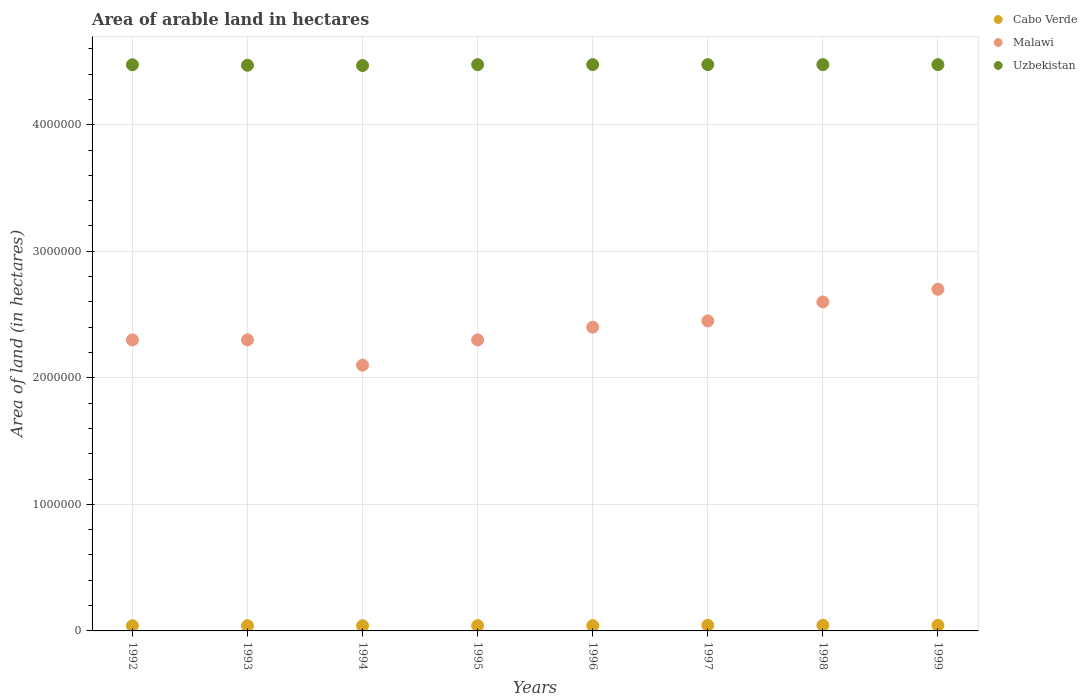What is the total arable land in Cabo Verde in 1999?
Your answer should be very brief. 4.40e+04. Across all years, what is the maximum total arable land in Malawi?
Your answer should be very brief. 2.70e+06. Across all years, what is the minimum total arable land in Cabo Verde?
Provide a short and direct response. 4.10e+04. In which year was the total arable land in Uzbekistan maximum?
Ensure brevity in your answer.  1995. In which year was the total arable land in Cabo Verde minimum?
Your response must be concise. 1992. What is the total total arable land in Cabo Verde in the graph?
Provide a succinct answer. 3.39e+05. What is the difference between the total arable land in Malawi in 1995 and that in 1999?
Keep it short and to the point. -4.00e+05. What is the difference between the total arable land in Cabo Verde in 1993 and the total arable land in Uzbekistan in 1995?
Your response must be concise. -4.43e+06. What is the average total arable land in Cabo Verde per year?
Ensure brevity in your answer.  4.24e+04. In the year 1998, what is the difference between the total arable land in Uzbekistan and total arable land in Malawi?
Your answer should be very brief. 1.88e+06. Is the total arable land in Uzbekistan in 1997 less than that in 1999?
Ensure brevity in your answer.  No. What is the difference between the highest and the second highest total arable land in Malawi?
Offer a terse response. 1.00e+05. What is the difference between the highest and the lowest total arable land in Cabo Verde?
Make the answer very short. 3000. In how many years, is the total arable land in Malawi greater than the average total arable land in Malawi taken over all years?
Provide a succinct answer. 4. Is the total arable land in Uzbekistan strictly greater than the total arable land in Cabo Verde over the years?
Your answer should be very brief. Yes. How many dotlines are there?
Ensure brevity in your answer.  3. Does the graph contain any zero values?
Ensure brevity in your answer.  No. Does the graph contain grids?
Make the answer very short. Yes. Where does the legend appear in the graph?
Your answer should be compact. Top right. How many legend labels are there?
Keep it short and to the point. 3. How are the legend labels stacked?
Offer a terse response. Vertical. What is the title of the graph?
Offer a terse response. Area of arable land in hectares. What is the label or title of the Y-axis?
Your answer should be compact. Area of land (in hectares). What is the Area of land (in hectares) in Cabo Verde in 1992?
Make the answer very short. 4.10e+04. What is the Area of land (in hectares) of Malawi in 1992?
Your response must be concise. 2.30e+06. What is the Area of land (in hectares) in Uzbekistan in 1992?
Make the answer very short. 4.47e+06. What is the Area of land (in hectares) in Cabo Verde in 1993?
Give a very brief answer. 4.10e+04. What is the Area of land (in hectares) of Malawi in 1993?
Provide a succinct answer. 2.30e+06. What is the Area of land (in hectares) of Uzbekistan in 1993?
Your answer should be very brief. 4.47e+06. What is the Area of land (in hectares) in Cabo Verde in 1994?
Provide a short and direct response. 4.10e+04. What is the Area of land (in hectares) in Malawi in 1994?
Give a very brief answer. 2.10e+06. What is the Area of land (in hectares) of Uzbekistan in 1994?
Ensure brevity in your answer.  4.47e+06. What is the Area of land (in hectares) in Cabo Verde in 1995?
Ensure brevity in your answer.  4.20e+04. What is the Area of land (in hectares) in Malawi in 1995?
Offer a terse response. 2.30e+06. What is the Area of land (in hectares) of Uzbekistan in 1995?
Keep it short and to the point. 4.48e+06. What is the Area of land (in hectares) of Cabo Verde in 1996?
Provide a short and direct response. 4.20e+04. What is the Area of land (in hectares) of Malawi in 1996?
Your answer should be compact. 2.40e+06. What is the Area of land (in hectares) in Uzbekistan in 1996?
Make the answer very short. 4.48e+06. What is the Area of land (in hectares) in Cabo Verde in 1997?
Your response must be concise. 4.40e+04. What is the Area of land (in hectares) in Malawi in 1997?
Offer a very short reply. 2.45e+06. What is the Area of land (in hectares) in Uzbekistan in 1997?
Ensure brevity in your answer.  4.48e+06. What is the Area of land (in hectares) of Cabo Verde in 1998?
Provide a succinct answer. 4.40e+04. What is the Area of land (in hectares) in Malawi in 1998?
Make the answer very short. 2.60e+06. What is the Area of land (in hectares) of Uzbekistan in 1998?
Your response must be concise. 4.48e+06. What is the Area of land (in hectares) of Cabo Verde in 1999?
Your answer should be compact. 4.40e+04. What is the Area of land (in hectares) of Malawi in 1999?
Provide a succinct answer. 2.70e+06. What is the Area of land (in hectares) of Uzbekistan in 1999?
Make the answer very short. 4.48e+06. Across all years, what is the maximum Area of land (in hectares) of Cabo Verde?
Ensure brevity in your answer.  4.40e+04. Across all years, what is the maximum Area of land (in hectares) in Malawi?
Provide a short and direct response. 2.70e+06. Across all years, what is the maximum Area of land (in hectares) of Uzbekistan?
Provide a short and direct response. 4.48e+06. Across all years, what is the minimum Area of land (in hectares) of Cabo Verde?
Provide a succinct answer. 4.10e+04. Across all years, what is the minimum Area of land (in hectares) in Malawi?
Offer a very short reply. 2.10e+06. Across all years, what is the minimum Area of land (in hectares) in Uzbekistan?
Provide a succinct answer. 4.47e+06. What is the total Area of land (in hectares) in Cabo Verde in the graph?
Your answer should be very brief. 3.39e+05. What is the total Area of land (in hectares) in Malawi in the graph?
Offer a very short reply. 1.92e+07. What is the total Area of land (in hectares) in Uzbekistan in the graph?
Offer a very short reply. 3.58e+07. What is the difference between the Area of land (in hectares) in Cabo Verde in 1992 and that in 1993?
Offer a very short reply. 0. What is the difference between the Area of land (in hectares) of Malawi in 1992 and that in 1993?
Offer a terse response. 0. What is the difference between the Area of land (in hectares) in Uzbekistan in 1992 and that in 1993?
Give a very brief answer. 4000. What is the difference between the Area of land (in hectares) of Uzbekistan in 1992 and that in 1994?
Offer a very short reply. 6000. What is the difference between the Area of land (in hectares) of Cabo Verde in 1992 and that in 1995?
Your response must be concise. -1000. What is the difference between the Area of land (in hectares) of Malawi in 1992 and that in 1995?
Make the answer very short. 0. What is the difference between the Area of land (in hectares) in Uzbekistan in 1992 and that in 1995?
Provide a succinct answer. -1000. What is the difference between the Area of land (in hectares) in Cabo Verde in 1992 and that in 1996?
Make the answer very short. -1000. What is the difference between the Area of land (in hectares) of Malawi in 1992 and that in 1996?
Ensure brevity in your answer.  -1.00e+05. What is the difference between the Area of land (in hectares) of Uzbekistan in 1992 and that in 1996?
Provide a succinct answer. -1000. What is the difference between the Area of land (in hectares) of Cabo Verde in 1992 and that in 1997?
Offer a terse response. -3000. What is the difference between the Area of land (in hectares) in Uzbekistan in 1992 and that in 1997?
Provide a short and direct response. -1000. What is the difference between the Area of land (in hectares) of Cabo Verde in 1992 and that in 1998?
Your response must be concise. -3000. What is the difference between the Area of land (in hectares) in Uzbekistan in 1992 and that in 1998?
Your answer should be very brief. -1000. What is the difference between the Area of land (in hectares) of Cabo Verde in 1992 and that in 1999?
Your response must be concise. -3000. What is the difference between the Area of land (in hectares) in Malawi in 1992 and that in 1999?
Provide a succinct answer. -4.00e+05. What is the difference between the Area of land (in hectares) of Uzbekistan in 1992 and that in 1999?
Your answer should be compact. -1000. What is the difference between the Area of land (in hectares) of Cabo Verde in 1993 and that in 1994?
Make the answer very short. 0. What is the difference between the Area of land (in hectares) in Uzbekistan in 1993 and that in 1994?
Provide a short and direct response. 2000. What is the difference between the Area of land (in hectares) in Cabo Verde in 1993 and that in 1995?
Offer a terse response. -1000. What is the difference between the Area of land (in hectares) in Malawi in 1993 and that in 1995?
Keep it short and to the point. 0. What is the difference between the Area of land (in hectares) in Uzbekistan in 1993 and that in 1995?
Your answer should be very brief. -5000. What is the difference between the Area of land (in hectares) of Cabo Verde in 1993 and that in 1996?
Offer a terse response. -1000. What is the difference between the Area of land (in hectares) of Uzbekistan in 1993 and that in 1996?
Provide a succinct answer. -5000. What is the difference between the Area of land (in hectares) in Cabo Verde in 1993 and that in 1997?
Provide a short and direct response. -3000. What is the difference between the Area of land (in hectares) in Uzbekistan in 1993 and that in 1997?
Provide a short and direct response. -5000. What is the difference between the Area of land (in hectares) of Cabo Verde in 1993 and that in 1998?
Ensure brevity in your answer.  -3000. What is the difference between the Area of land (in hectares) of Uzbekistan in 1993 and that in 1998?
Offer a very short reply. -5000. What is the difference between the Area of land (in hectares) in Cabo Verde in 1993 and that in 1999?
Ensure brevity in your answer.  -3000. What is the difference between the Area of land (in hectares) of Malawi in 1993 and that in 1999?
Give a very brief answer. -4.00e+05. What is the difference between the Area of land (in hectares) of Uzbekistan in 1993 and that in 1999?
Make the answer very short. -5000. What is the difference between the Area of land (in hectares) of Cabo Verde in 1994 and that in 1995?
Ensure brevity in your answer.  -1000. What is the difference between the Area of land (in hectares) of Malawi in 1994 and that in 1995?
Provide a short and direct response. -2.00e+05. What is the difference between the Area of land (in hectares) of Uzbekistan in 1994 and that in 1995?
Provide a succinct answer. -7000. What is the difference between the Area of land (in hectares) in Cabo Verde in 1994 and that in 1996?
Keep it short and to the point. -1000. What is the difference between the Area of land (in hectares) of Malawi in 1994 and that in 1996?
Your response must be concise. -3.00e+05. What is the difference between the Area of land (in hectares) of Uzbekistan in 1994 and that in 1996?
Provide a succinct answer. -7000. What is the difference between the Area of land (in hectares) of Cabo Verde in 1994 and that in 1997?
Ensure brevity in your answer.  -3000. What is the difference between the Area of land (in hectares) in Malawi in 1994 and that in 1997?
Ensure brevity in your answer.  -3.50e+05. What is the difference between the Area of land (in hectares) of Uzbekistan in 1994 and that in 1997?
Ensure brevity in your answer.  -7000. What is the difference between the Area of land (in hectares) in Cabo Verde in 1994 and that in 1998?
Give a very brief answer. -3000. What is the difference between the Area of land (in hectares) in Malawi in 1994 and that in 1998?
Provide a short and direct response. -5.00e+05. What is the difference between the Area of land (in hectares) of Uzbekistan in 1994 and that in 1998?
Offer a terse response. -7000. What is the difference between the Area of land (in hectares) in Cabo Verde in 1994 and that in 1999?
Keep it short and to the point. -3000. What is the difference between the Area of land (in hectares) in Malawi in 1994 and that in 1999?
Provide a short and direct response. -6.00e+05. What is the difference between the Area of land (in hectares) in Uzbekistan in 1994 and that in 1999?
Offer a very short reply. -7000. What is the difference between the Area of land (in hectares) in Uzbekistan in 1995 and that in 1996?
Give a very brief answer. 0. What is the difference between the Area of land (in hectares) of Cabo Verde in 1995 and that in 1997?
Offer a terse response. -2000. What is the difference between the Area of land (in hectares) in Cabo Verde in 1995 and that in 1998?
Provide a succinct answer. -2000. What is the difference between the Area of land (in hectares) of Uzbekistan in 1995 and that in 1998?
Your answer should be compact. 0. What is the difference between the Area of land (in hectares) in Cabo Verde in 1995 and that in 1999?
Your answer should be compact. -2000. What is the difference between the Area of land (in hectares) of Malawi in 1995 and that in 1999?
Make the answer very short. -4.00e+05. What is the difference between the Area of land (in hectares) of Cabo Verde in 1996 and that in 1997?
Make the answer very short. -2000. What is the difference between the Area of land (in hectares) of Malawi in 1996 and that in 1997?
Your response must be concise. -5.00e+04. What is the difference between the Area of land (in hectares) in Uzbekistan in 1996 and that in 1997?
Provide a succinct answer. 0. What is the difference between the Area of land (in hectares) of Cabo Verde in 1996 and that in 1998?
Offer a very short reply. -2000. What is the difference between the Area of land (in hectares) in Malawi in 1996 and that in 1998?
Your answer should be compact. -2.00e+05. What is the difference between the Area of land (in hectares) in Cabo Verde in 1996 and that in 1999?
Provide a succinct answer. -2000. What is the difference between the Area of land (in hectares) in Malawi in 1997 and that in 1998?
Your answer should be compact. -1.50e+05. What is the difference between the Area of land (in hectares) of Uzbekistan in 1997 and that in 1998?
Give a very brief answer. 0. What is the difference between the Area of land (in hectares) of Malawi in 1997 and that in 1999?
Give a very brief answer. -2.50e+05. What is the difference between the Area of land (in hectares) of Cabo Verde in 1998 and that in 1999?
Make the answer very short. 0. What is the difference between the Area of land (in hectares) of Malawi in 1998 and that in 1999?
Ensure brevity in your answer.  -1.00e+05. What is the difference between the Area of land (in hectares) in Cabo Verde in 1992 and the Area of land (in hectares) in Malawi in 1993?
Keep it short and to the point. -2.26e+06. What is the difference between the Area of land (in hectares) of Cabo Verde in 1992 and the Area of land (in hectares) of Uzbekistan in 1993?
Your response must be concise. -4.43e+06. What is the difference between the Area of land (in hectares) in Malawi in 1992 and the Area of land (in hectares) in Uzbekistan in 1993?
Make the answer very short. -2.17e+06. What is the difference between the Area of land (in hectares) of Cabo Verde in 1992 and the Area of land (in hectares) of Malawi in 1994?
Keep it short and to the point. -2.06e+06. What is the difference between the Area of land (in hectares) in Cabo Verde in 1992 and the Area of land (in hectares) in Uzbekistan in 1994?
Keep it short and to the point. -4.43e+06. What is the difference between the Area of land (in hectares) of Malawi in 1992 and the Area of land (in hectares) of Uzbekistan in 1994?
Your response must be concise. -2.17e+06. What is the difference between the Area of land (in hectares) of Cabo Verde in 1992 and the Area of land (in hectares) of Malawi in 1995?
Offer a very short reply. -2.26e+06. What is the difference between the Area of land (in hectares) of Cabo Verde in 1992 and the Area of land (in hectares) of Uzbekistan in 1995?
Provide a succinct answer. -4.43e+06. What is the difference between the Area of land (in hectares) of Malawi in 1992 and the Area of land (in hectares) of Uzbekistan in 1995?
Your response must be concise. -2.18e+06. What is the difference between the Area of land (in hectares) in Cabo Verde in 1992 and the Area of land (in hectares) in Malawi in 1996?
Your answer should be very brief. -2.36e+06. What is the difference between the Area of land (in hectares) of Cabo Verde in 1992 and the Area of land (in hectares) of Uzbekistan in 1996?
Your answer should be compact. -4.43e+06. What is the difference between the Area of land (in hectares) in Malawi in 1992 and the Area of land (in hectares) in Uzbekistan in 1996?
Your answer should be very brief. -2.18e+06. What is the difference between the Area of land (in hectares) in Cabo Verde in 1992 and the Area of land (in hectares) in Malawi in 1997?
Your response must be concise. -2.41e+06. What is the difference between the Area of land (in hectares) of Cabo Verde in 1992 and the Area of land (in hectares) of Uzbekistan in 1997?
Offer a terse response. -4.43e+06. What is the difference between the Area of land (in hectares) in Malawi in 1992 and the Area of land (in hectares) in Uzbekistan in 1997?
Give a very brief answer. -2.18e+06. What is the difference between the Area of land (in hectares) in Cabo Verde in 1992 and the Area of land (in hectares) in Malawi in 1998?
Your answer should be compact. -2.56e+06. What is the difference between the Area of land (in hectares) of Cabo Verde in 1992 and the Area of land (in hectares) of Uzbekistan in 1998?
Ensure brevity in your answer.  -4.43e+06. What is the difference between the Area of land (in hectares) of Malawi in 1992 and the Area of land (in hectares) of Uzbekistan in 1998?
Offer a terse response. -2.18e+06. What is the difference between the Area of land (in hectares) in Cabo Verde in 1992 and the Area of land (in hectares) in Malawi in 1999?
Make the answer very short. -2.66e+06. What is the difference between the Area of land (in hectares) of Cabo Verde in 1992 and the Area of land (in hectares) of Uzbekistan in 1999?
Your answer should be very brief. -4.43e+06. What is the difference between the Area of land (in hectares) in Malawi in 1992 and the Area of land (in hectares) in Uzbekistan in 1999?
Your answer should be compact. -2.18e+06. What is the difference between the Area of land (in hectares) in Cabo Verde in 1993 and the Area of land (in hectares) in Malawi in 1994?
Keep it short and to the point. -2.06e+06. What is the difference between the Area of land (in hectares) of Cabo Verde in 1993 and the Area of land (in hectares) of Uzbekistan in 1994?
Your response must be concise. -4.43e+06. What is the difference between the Area of land (in hectares) in Malawi in 1993 and the Area of land (in hectares) in Uzbekistan in 1994?
Keep it short and to the point. -2.17e+06. What is the difference between the Area of land (in hectares) of Cabo Verde in 1993 and the Area of land (in hectares) of Malawi in 1995?
Give a very brief answer. -2.26e+06. What is the difference between the Area of land (in hectares) in Cabo Verde in 1993 and the Area of land (in hectares) in Uzbekistan in 1995?
Give a very brief answer. -4.43e+06. What is the difference between the Area of land (in hectares) in Malawi in 1993 and the Area of land (in hectares) in Uzbekistan in 1995?
Keep it short and to the point. -2.18e+06. What is the difference between the Area of land (in hectares) of Cabo Verde in 1993 and the Area of land (in hectares) of Malawi in 1996?
Give a very brief answer. -2.36e+06. What is the difference between the Area of land (in hectares) in Cabo Verde in 1993 and the Area of land (in hectares) in Uzbekistan in 1996?
Make the answer very short. -4.43e+06. What is the difference between the Area of land (in hectares) in Malawi in 1993 and the Area of land (in hectares) in Uzbekistan in 1996?
Make the answer very short. -2.18e+06. What is the difference between the Area of land (in hectares) of Cabo Verde in 1993 and the Area of land (in hectares) of Malawi in 1997?
Offer a terse response. -2.41e+06. What is the difference between the Area of land (in hectares) of Cabo Verde in 1993 and the Area of land (in hectares) of Uzbekistan in 1997?
Your answer should be very brief. -4.43e+06. What is the difference between the Area of land (in hectares) in Malawi in 1993 and the Area of land (in hectares) in Uzbekistan in 1997?
Provide a succinct answer. -2.18e+06. What is the difference between the Area of land (in hectares) of Cabo Verde in 1993 and the Area of land (in hectares) of Malawi in 1998?
Provide a succinct answer. -2.56e+06. What is the difference between the Area of land (in hectares) of Cabo Verde in 1993 and the Area of land (in hectares) of Uzbekistan in 1998?
Provide a succinct answer. -4.43e+06. What is the difference between the Area of land (in hectares) of Malawi in 1993 and the Area of land (in hectares) of Uzbekistan in 1998?
Provide a succinct answer. -2.18e+06. What is the difference between the Area of land (in hectares) of Cabo Verde in 1993 and the Area of land (in hectares) of Malawi in 1999?
Ensure brevity in your answer.  -2.66e+06. What is the difference between the Area of land (in hectares) of Cabo Verde in 1993 and the Area of land (in hectares) of Uzbekistan in 1999?
Your response must be concise. -4.43e+06. What is the difference between the Area of land (in hectares) in Malawi in 1993 and the Area of land (in hectares) in Uzbekistan in 1999?
Keep it short and to the point. -2.18e+06. What is the difference between the Area of land (in hectares) of Cabo Verde in 1994 and the Area of land (in hectares) of Malawi in 1995?
Your response must be concise. -2.26e+06. What is the difference between the Area of land (in hectares) of Cabo Verde in 1994 and the Area of land (in hectares) of Uzbekistan in 1995?
Keep it short and to the point. -4.43e+06. What is the difference between the Area of land (in hectares) in Malawi in 1994 and the Area of land (in hectares) in Uzbekistan in 1995?
Offer a very short reply. -2.38e+06. What is the difference between the Area of land (in hectares) of Cabo Verde in 1994 and the Area of land (in hectares) of Malawi in 1996?
Keep it short and to the point. -2.36e+06. What is the difference between the Area of land (in hectares) in Cabo Verde in 1994 and the Area of land (in hectares) in Uzbekistan in 1996?
Ensure brevity in your answer.  -4.43e+06. What is the difference between the Area of land (in hectares) in Malawi in 1994 and the Area of land (in hectares) in Uzbekistan in 1996?
Your answer should be very brief. -2.38e+06. What is the difference between the Area of land (in hectares) in Cabo Verde in 1994 and the Area of land (in hectares) in Malawi in 1997?
Offer a very short reply. -2.41e+06. What is the difference between the Area of land (in hectares) in Cabo Verde in 1994 and the Area of land (in hectares) in Uzbekistan in 1997?
Provide a succinct answer. -4.43e+06. What is the difference between the Area of land (in hectares) in Malawi in 1994 and the Area of land (in hectares) in Uzbekistan in 1997?
Provide a short and direct response. -2.38e+06. What is the difference between the Area of land (in hectares) in Cabo Verde in 1994 and the Area of land (in hectares) in Malawi in 1998?
Ensure brevity in your answer.  -2.56e+06. What is the difference between the Area of land (in hectares) of Cabo Verde in 1994 and the Area of land (in hectares) of Uzbekistan in 1998?
Give a very brief answer. -4.43e+06. What is the difference between the Area of land (in hectares) of Malawi in 1994 and the Area of land (in hectares) of Uzbekistan in 1998?
Your answer should be very brief. -2.38e+06. What is the difference between the Area of land (in hectares) of Cabo Verde in 1994 and the Area of land (in hectares) of Malawi in 1999?
Give a very brief answer. -2.66e+06. What is the difference between the Area of land (in hectares) in Cabo Verde in 1994 and the Area of land (in hectares) in Uzbekistan in 1999?
Your answer should be compact. -4.43e+06. What is the difference between the Area of land (in hectares) in Malawi in 1994 and the Area of land (in hectares) in Uzbekistan in 1999?
Your response must be concise. -2.38e+06. What is the difference between the Area of land (in hectares) in Cabo Verde in 1995 and the Area of land (in hectares) in Malawi in 1996?
Make the answer very short. -2.36e+06. What is the difference between the Area of land (in hectares) of Cabo Verde in 1995 and the Area of land (in hectares) of Uzbekistan in 1996?
Your answer should be compact. -4.43e+06. What is the difference between the Area of land (in hectares) of Malawi in 1995 and the Area of land (in hectares) of Uzbekistan in 1996?
Give a very brief answer. -2.18e+06. What is the difference between the Area of land (in hectares) of Cabo Verde in 1995 and the Area of land (in hectares) of Malawi in 1997?
Your answer should be compact. -2.41e+06. What is the difference between the Area of land (in hectares) in Cabo Verde in 1995 and the Area of land (in hectares) in Uzbekistan in 1997?
Give a very brief answer. -4.43e+06. What is the difference between the Area of land (in hectares) of Malawi in 1995 and the Area of land (in hectares) of Uzbekistan in 1997?
Provide a short and direct response. -2.18e+06. What is the difference between the Area of land (in hectares) of Cabo Verde in 1995 and the Area of land (in hectares) of Malawi in 1998?
Your response must be concise. -2.56e+06. What is the difference between the Area of land (in hectares) of Cabo Verde in 1995 and the Area of land (in hectares) of Uzbekistan in 1998?
Provide a succinct answer. -4.43e+06. What is the difference between the Area of land (in hectares) of Malawi in 1995 and the Area of land (in hectares) of Uzbekistan in 1998?
Your answer should be very brief. -2.18e+06. What is the difference between the Area of land (in hectares) of Cabo Verde in 1995 and the Area of land (in hectares) of Malawi in 1999?
Your response must be concise. -2.66e+06. What is the difference between the Area of land (in hectares) in Cabo Verde in 1995 and the Area of land (in hectares) in Uzbekistan in 1999?
Make the answer very short. -4.43e+06. What is the difference between the Area of land (in hectares) in Malawi in 1995 and the Area of land (in hectares) in Uzbekistan in 1999?
Offer a terse response. -2.18e+06. What is the difference between the Area of land (in hectares) of Cabo Verde in 1996 and the Area of land (in hectares) of Malawi in 1997?
Keep it short and to the point. -2.41e+06. What is the difference between the Area of land (in hectares) of Cabo Verde in 1996 and the Area of land (in hectares) of Uzbekistan in 1997?
Offer a very short reply. -4.43e+06. What is the difference between the Area of land (in hectares) in Malawi in 1996 and the Area of land (in hectares) in Uzbekistan in 1997?
Provide a succinct answer. -2.08e+06. What is the difference between the Area of land (in hectares) in Cabo Verde in 1996 and the Area of land (in hectares) in Malawi in 1998?
Your answer should be compact. -2.56e+06. What is the difference between the Area of land (in hectares) in Cabo Verde in 1996 and the Area of land (in hectares) in Uzbekistan in 1998?
Your answer should be compact. -4.43e+06. What is the difference between the Area of land (in hectares) in Malawi in 1996 and the Area of land (in hectares) in Uzbekistan in 1998?
Keep it short and to the point. -2.08e+06. What is the difference between the Area of land (in hectares) of Cabo Verde in 1996 and the Area of land (in hectares) of Malawi in 1999?
Offer a very short reply. -2.66e+06. What is the difference between the Area of land (in hectares) of Cabo Verde in 1996 and the Area of land (in hectares) of Uzbekistan in 1999?
Your answer should be compact. -4.43e+06. What is the difference between the Area of land (in hectares) in Malawi in 1996 and the Area of land (in hectares) in Uzbekistan in 1999?
Provide a succinct answer. -2.08e+06. What is the difference between the Area of land (in hectares) in Cabo Verde in 1997 and the Area of land (in hectares) in Malawi in 1998?
Offer a very short reply. -2.56e+06. What is the difference between the Area of land (in hectares) of Cabo Verde in 1997 and the Area of land (in hectares) of Uzbekistan in 1998?
Your answer should be compact. -4.43e+06. What is the difference between the Area of land (in hectares) of Malawi in 1997 and the Area of land (in hectares) of Uzbekistan in 1998?
Your answer should be very brief. -2.02e+06. What is the difference between the Area of land (in hectares) of Cabo Verde in 1997 and the Area of land (in hectares) of Malawi in 1999?
Offer a terse response. -2.66e+06. What is the difference between the Area of land (in hectares) of Cabo Verde in 1997 and the Area of land (in hectares) of Uzbekistan in 1999?
Offer a terse response. -4.43e+06. What is the difference between the Area of land (in hectares) of Malawi in 1997 and the Area of land (in hectares) of Uzbekistan in 1999?
Keep it short and to the point. -2.02e+06. What is the difference between the Area of land (in hectares) of Cabo Verde in 1998 and the Area of land (in hectares) of Malawi in 1999?
Offer a very short reply. -2.66e+06. What is the difference between the Area of land (in hectares) of Cabo Verde in 1998 and the Area of land (in hectares) of Uzbekistan in 1999?
Your answer should be very brief. -4.43e+06. What is the difference between the Area of land (in hectares) of Malawi in 1998 and the Area of land (in hectares) of Uzbekistan in 1999?
Provide a short and direct response. -1.88e+06. What is the average Area of land (in hectares) of Cabo Verde per year?
Your answer should be compact. 4.24e+04. What is the average Area of land (in hectares) in Malawi per year?
Make the answer very short. 2.39e+06. What is the average Area of land (in hectares) of Uzbekistan per year?
Make the answer very short. 4.47e+06. In the year 1992, what is the difference between the Area of land (in hectares) of Cabo Verde and Area of land (in hectares) of Malawi?
Your response must be concise. -2.26e+06. In the year 1992, what is the difference between the Area of land (in hectares) of Cabo Verde and Area of land (in hectares) of Uzbekistan?
Your answer should be compact. -4.43e+06. In the year 1992, what is the difference between the Area of land (in hectares) of Malawi and Area of land (in hectares) of Uzbekistan?
Make the answer very short. -2.17e+06. In the year 1993, what is the difference between the Area of land (in hectares) in Cabo Verde and Area of land (in hectares) in Malawi?
Your answer should be compact. -2.26e+06. In the year 1993, what is the difference between the Area of land (in hectares) of Cabo Verde and Area of land (in hectares) of Uzbekistan?
Offer a terse response. -4.43e+06. In the year 1993, what is the difference between the Area of land (in hectares) in Malawi and Area of land (in hectares) in Uzbekistan?
Your answer should be very brief. -2.17e+06. In the year 1994, what is the difference between the Area of land (in hectares) of Cabo Verde and Area of land (in hectares) of Malawi?
Give a very brief answer. -2.06e+06. In the year 1994, what is the difference between the Area of land (in hectares) in Cabo Verde and Area of land (in hectares) in Uzbekistan?
Your answer should be very brief. -4.43e+06. In the year 1994, what is the difference between the Area of land (in hectares) in Malawi and Area of land (in hectares) in Uzbekistan?
Provide a short and direct response. -2.37e+06. In the year 1995, what is the difference between the Area of land (in hectares) of Cabo Verde and Area of land (in hectares) of Malawi?
Make the answer very short. -2.26e+06. In the year 1995, what is the difference between the Area of land (in hectares) of Cabo Verde and Area of land (in hectares) of Uzbekistan?
Your response must be concise. -4.43e+06. In the year 1995, what is the difference between the Area of land (in hectares) of Malawi and Area of land (in hectares) of Uzbekistan?
Keep it short and to the point. -2.18e+06. In the year 1996, what is the difference between the Area of land (in hectares) of Cabo Verde and Area of land (in hectares) of Malawi?
Your answer should be very brief. -2.36e+06. In the year 1996, what is the difference between the Area of land (in hectares) of Cabo Verde and Area of land (in hectares) of Uzbekistan?
Your answer should be very brief. -4.43e+06. In the year 1996, what is the difference between the Area of land (in hectares) of Malawi and Area of land (in hectares) of Uzbekistan?
Your answer should be compact. -2.08e+06. In the year 1997, what is the difference between the Area of land (in hectares) of Cabo Verde and Area of land (in hectares) of Malawi?
Keep it short and to the point. -2.41e+06. In the year 1997, what is the difference between the Area of land (in hectares) in Cabo Verde and Area of land (in hectares) in Uzbekistan?
Your answer should be compact. -4.43e+06. In the year 1997, what is the difference between the Area of land (in hectares) of Malawi and Area of land (in hectares) of Uzbekistan?
Make the answer very short. -2.02e+06. In the year 1998, what is the difference between the Area of land (in hectares) in Cabo Verde and Area of land (in hectares) in Malawi?
Keep it short and to the point. -2.56e+06. In the year 1998, what is the difference between the Area of land (in hectares) in Cabo Verde and Area of land (in hectares) in Uzbekistan?
Provide a short and direct response. -4.43e+06. In the year 1998, what is the difference between the Area of land (in hectares) of Malawi and Area of land (in hectares) of Uzbekistan?
Offer a terse response. -1.88e+06. In the year 1999, what is the difference between the Area of land (in hectares) in Cabo Verde and Area of land (in hectares) in Malawi?
Your answer should be very brief. -2.66e+06. In the year 1999, what is the difference between the Area of land (in hectares) in Cabo Verde and Area of land (in hectares) in Uzbekistan?
Provide a short and direct response. -4.43e+06. In the year 1999, what is the difference between the Area of land (in hectares) in Malawi and Area of land (in hectares) in Uzbekistan?
Your response must be concise. -1.78e+06. What is the ratio of the Area of land (in hectares) of Malawi in 1992 to that in 1994?
Provide a succinct answer. 1.1. What is the ratio of the Area of land (in hectares) of Cabo Verde in 1992 to that in 1995?
Your answer should be very brief. 0.98. What is the ratio of the Area of land (in hectares) of Malawi in 1992 to that in 1995?
Your answer should be compact. 1. What is the ratio of the Area of land (in hectares) in Uzbekistan in 1992 to that in 1995?
Your answer should be very brief. 1. What is the ratio of the Area of land (in hectares) of Cabo Verde in 1992 to that in 1996?
Offer a terse response. 0.98. What is the ratio of the Area of land (in hectares) in Uzbekistan in 1992 to that in 1996?
Make the answer very short. 1. What is the ratio of the Area of land (in hectares) of Cabo Verde in 1992 to that in 1997?
Give a very brief answer. 0.93. What is the ratio of the Area of land (in hectares) of Malawi in 1992 to that in 1997?
Your answer should be compact. 0.94. What is the ratio of the Area of land (in hectares) of Cabo Verde in 1992 to that in 1998?
Provide a short and direct response. 0.93. What is the ratio of the Area of land (in hectares) in Malawi in 1992 to that in 1998?
Your response must be concise. 0.88. What is the ratio of the Area of land (in hectares) of Uzbekistan in 1992 to that in 1998?
Offer a very short reply. 1. What is the ratio of the Area of land (in hectares) in Cabo Verde in 1992 to that in 1999?
Keep it short and to the point. 0.93. What is the ratio of the Area of land (in hectares) in Malawi in 1992 to that in 1999?
Offer a very short reply. 0.85. What is the ratio of the Area of land (in hectares) of Cabo Verde in 1993 to that in 1994?
Provide a succinct answer. 1. What is the ratio of the Area of land (in hectares) in Malawi in 1993 to that in 1994?
Make the answer very short. 1.1. What is the ratio of the Area of land (in hectares) in Uzbekistan in 1993 to that in 1994?
Keep it short and to the point. 1. What is the ratio of the Area of land (in hectares) of Cabo Verde in 1993 to that in 1995?
Offer a terse response. 0.98. What is the ratio of the Area of land (in hectares) of Malawi in 1993 to that in 1995?
Provide a succinct answer. 1. What is the ratio of the Area of land (in hectares) in Uzbekistan in 1993 to that in 1995?
Your answer should be very brief. 1. What is the ratio of the Area of land (in hectares) in Cabo Verde in 1993 to that in 1996?
Offer a very short reply. 0.98. What is the ratio of the Area of land (in hectares) of Uzbekistan in 1993 to that in 1996?
Make the answer very short. 1. What is the ratio of the Area of land (in hectares) in Cabo Verde in 1993 to that in 1997?
Keep it short and to the point. 0.93. What is the ratio of the Area of land (in hectares) in Malawi in 1993 to that in 1997?
Keep it short and to the point. 0.94. What is the ratio of the Area of land (in hectares) in Uzbekistan in 1993 to that in 1997?
Offer a terse response. 1. What is the ratio of the Area of land (in hectares) in Cabo Verde in 1993 to that in 1998?
Offer a very short reply. 0.93. What is the ratio of the Area of land (in hectares) of Malawi in 1993 to that in 1998?
Your response must be concise. 0.88. What is the ratio of the Area of land (in hectares) of Cabo Verde in 1993 to that in 1999?
Your answer should be very brief. 0.93. What is the ratio of the Area of land (in hectares) in Malawi in 1993 to that in 1999?
Your answer should be compact. 0.85. What is the ratio of the Area of land (in hectares) of Uzbekistan in 1993 to that in 1999?
Make the answer very short. 1. What is the ratio of the Area of land (in hectares) in Cabo Verde in 1994 to that in 1995?
Offer a very short reply. 0.98. What is the ratio of the Area of land (in hectares) of Uzbekistan in 1994 to that in 1995?
Give a very brief answer. 1. What is the ratio of the Area of land (in hectares) of Cabo Verde in 1994 to that in 1996?
Ensure brevity in your answer.  0.98. What is the ratio of the Area of land (in hectares) in Cabo Verde in 1994 to that in 1997?
Keep it short and to the point. 0.93. What is the ratio of the Area of land (in hectares) of Uzbekistan in 1994 to that in 1997?
Offer a terse response. 1. What is the ratio of the Area of land (in hectares) of Cabo Verde in 1994 to that in 1998?
Offer a very short reply. 0.93. What is the ratio of the Area of land (in hectares) of Malawi in 1994 to that in 1998?
Provide a succinct answer. 0.81. What is the ratio of the Area of land (in hectares) of Cabo Verde in 1994 to that in 1999?
Give a very brief answer. 0.93. What is the ratio of the Area of land (in hectares) in Uzbekistan in 1994 to that in 1999?
Give a very brief answer. 1. What is the ratio of the Area of land (in hectares) in Uzbekistan in 1995 to that in 1996?
Offer a very short reply. 1. What is the ratio of the Area of land (in hectares) of Cabo Verde in 1995 to that in 1997?
Give a very brief answer. 0.95. What is the ratio of the Area of land (in hectares) of Malawi in 1995 to that in 1997?
Your answer should be compact. 0.94. What is the ratio of the Area of land (in hectares) in Uzbekistan in 1995 to that in 1997?
Give a very brief answer. 1. What is the ratio of the Area of land (in hectares) in Cabo Verde in 1995 to that in 1998?
Give a very brief answer. 0.95. What is the ratio of the Area of land (in hectares) in Malawi in 1995 to that in 1998?
Provide a succinct answer. 0.88. What is the ratio of the Area of land (in hectares) in Cabo Verde in 1995 to that in 1999?
Offer a terse response. 0.95. What is the ratio of the Area of land (in hectares) of Malawi in 1995 to that in 1999?
Provide a succinct answer. 0.85. What is the ratio of the Area of land (in hectares) of Uzbekistan in 1995 to that in 1999?
Make the answer very short. 1. What is the ratio of the Area of land (in hectares) in Cabo Verde in 1996 to that in 1997?
Your response must be concise. 0.95. What is the ratio of the Area of land (in hectares) of Malawi in 1996 to that in 1997?
Offer a very short reply. 0.98. What is the ratio of the Area of land (in hectares) of Cabo Verde in 1996 to that in 1998?
Provide a short and direct response. 0.95. What is the ratio of the Area of land (in hectares) of Uzbekistan in 1996 to that in 1998?
Make the answer very short. 1. What is the ratio of the Area of land (in hectares) of Cabo Verde in 1996 to that in 1999?
Offer a very short reply. 0.95. What is the ratio of the Area of land (in hectares) in Malawi in 1996 to that in 1999?
Offer a terse response. 0.89. What is the ratio of the Area of land (in hectares) in Malawi in 1997 to that in 1998?
Offer a terse response. 0.94. What is the ratio of the Area of land (in hectares) in Malawi in 1997 to that in 1999?
Make the answer very short. 0.91. What is the ratio of the Area of land (in hectares) of Cabo Verde in 1998 to that in 1999?
Provide a short and direct response. 1. What is the ratio of the Area of land (in hectares) in Malawi in 1998 to that in 1999?
Offer a terse response. 0.96. What is the ratio of the Area of land (in hectares) of Uzbekistan in 1998 to that in 1999?
Your answer should be compact. 1. What is the difference between the highest and the lowest Area of land (in hectares) in Cabo Verde?
Give a very brief answer. 3000. What is the difference between the highest and the lowest Area of land (in hectares) in Malawi?
Provide a short and direct response. 6.00e+05. What is the difference between the highest and the lowest Area of land (in hectares) of Uzbekistan?
Give a very brief answer. 7000. 